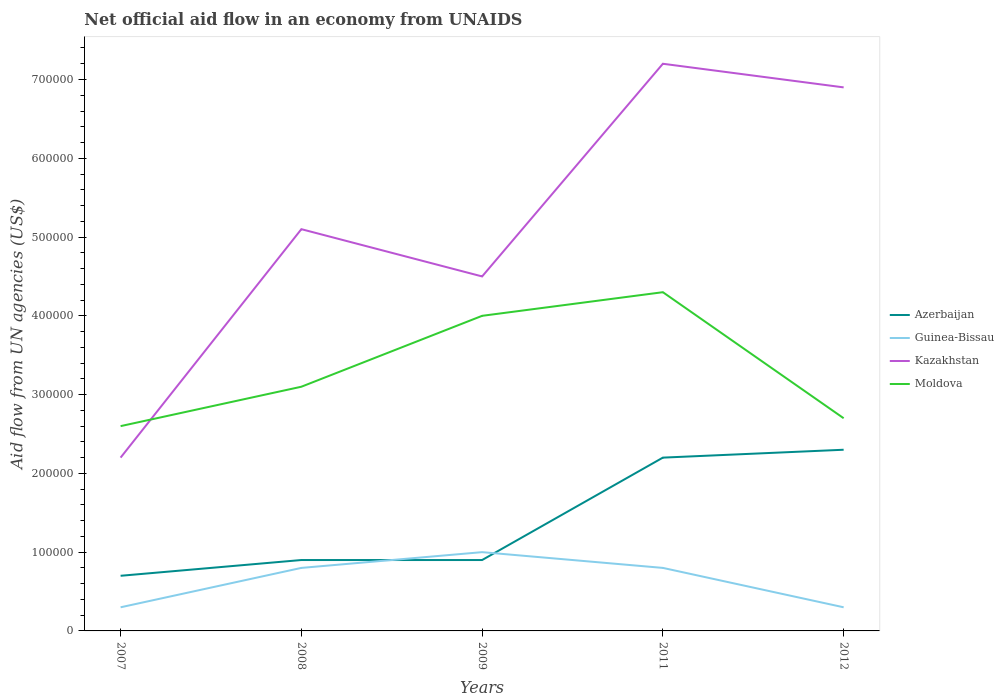Across all years, what is the maximum net official aid flow in Kazakhstan?
Offer a very short reply. 2.20e+05. In which year was the net official aid flow in Guinea-Bissau maximum?
Keep it short and to the point. 2007. What is the total net official aid flow in Kazakhstan in the graph?
Offer a very short reply. -2.40e+05. What is the difference between the highest and the second highest net official aid flow in Kazakhstan?
Keep it short and to the point. 5.00e+05. What is the difference between two consecutive major ticks on the Y-axis?
Your response must be concise. 1.00e+05. Does the graph contain any zero values?
Give a very brief answer. No. What is the title of the graph?
Give a very brief answer. Net official aid flow in an economy from UNAIDS. What is the label or title of the X-axis?
Ensure brevity in your answer.  Years. What is the label or title of the Y-axis?
Make the answer very short. Aid flow from UN agencies (US$). What is the Aid flow from UN agencies (US$) of Azerbaijan in 2007?
Provide a short and direct response. 7.00e+04. What is the Aid flow from UN agencies (US$) in Kazakhstan in 2007?
Provide a succinct answer. 2.20e+05. What is the Aid flow from UN agencies (US$) in Guinea-Bissau in 2008?
Offer a terse response. 8.00e+04. What is the Aid flow from UN agencies (US$) of Kazakhstan in 2008?
Your response must be concise. 5.10e+05. What is the Aid flow from UN agencies (US$) in Moldova in 2008?
Ensure brevity in your answer.  3.10e+05. What is the Aid flow from UN agencies (US$) of Azerbaijan in 2009?
Your response must be concise. 9.00e+04. What is the Aid flow from UN agencies (US$) in Moldova in 2009?
Make the answer very short. 4.00e+05. What is the Aid flow from UN agencies (US$) in Kazakhstan in 2011?
Offer a terse response. 7.20e+05. What is the Aid flow from UN agencies (US$) in Azerbaijan in 2012?
Make the answer very short. 2.30e+05. What is the Aid flow from UN agencies (US$) in Guinea-Bissau in 2012?
Your answer should be compact. 3.00e+04. What is the Aid flow from UN agencies (US$) in Kazakhstan in 2012?
Provide a short and direct response. 6.90e+05. What is the Aid flow from UN agencies (US$) in Moldova in 2012?
Offer a terse response. 2.70e+05. Across all years, what is the maximum Aid flow from UN agencies (US$) in Azerbaijan?
Ensure brevity in your answer.  2.30e+05. Across all years, what is the maximum Aid flow from UN agencies (US$) in Kazakhstan?
Offer a terse response. 7.20e+05. Across all years, what is the maximum Aid flow from UN agencies (US$) in Moldova?
Offer a very short reply. 4.30e+05. Across all years, what is the minimum Aid flow from UN agencies (US$) of Azerbaijan?
Offer a terse response. 7.00e+04. What is the total Aid flow from UN agencies (US$) in Azerbaijan in the graph?
Provide a short and direct response. 7.00e+05. What is the total Aid flow from UN agencies (US$) of Guinea-Bissau in the graph?
Ensure brevity in your answer.  3.20e+05. What is the total Aid flow from UN agencies (US$) in Kazakhstan in the graph?
Your response must be concise. 2.59e+06. What is the total Aid flow from UN agencies (US$) of Moldova in the graph?
Your answer should be very brief. 1.67e+06. What is the difference between the Aid flow from UN agencies (US$) in Azerbaijan in 2007 and that in 2008?
Keep it short and to the point. -2.00e+04. What is the difference between the Aid flow from UN agencies (US$) in Guinea-Bissau in 2007 and that in 2008?
Offer a terse response. -5.00e+04. What is the difference between the Aid flow from UN agencies (US$) of Azerbaijan in 2007 and that in 2009?
Offer a very short reply. -2.00e+04. What is the difference between the Aid flow from UN agencies (US$) in Guinea-Bissau in 2007 and that in 2011?
Offer a terse response. -5.00e+04. What is the difference between the Aid flow from UN agencies (US$) in Kazakhstan in 2007 and that in 2011?
Offer a very short reply. -5.00e+05. What is the difference between the Aid flow from UN agencies (US$) of Kazakhstan in 2007 and that in 2012?
Your answer should be very brief. -4.70e+05. What is the difference between the Aid flow from UN agencies (US$) of Azerbaijan in 2008 and that in 2009?
Make the answer very short. 0. What is the difference between the Aid flow from UN agencies (US$) in Guinea-Bissau in 2008 and that in 2009?
Keep it short and to the point. -2.00e+04. What is the difference between the Aid flow from UN agencies (US$) in Kazakhstan in 2008 and that in 2009?
Your response must be concise. 6.00e+04. What is the difference between the Aid flow from UN agencies (US$) in Moldova in 2008 and that in 2009?
Provide a short and direct response. -9.00e+04. What is the difference between the Aid flow from UN agencies (US$) in Kazakhstan in 2008 and that in 2011?
Offer a very short reply. -2.10e+05. What is the difference between the Aid flow from UN agencies (US$) in Guinea-Bissau in 2008 and that in 2012?
Your answer should be compact. 5.00e+04. What is the difference between the Aid flow from UN agencies (US$) in Kazakhstan in 2008 and that in 2012?
Give a very brief answer. -1.80e+05. What is the difference between the Aid flow from UN agencies (US$) of Moldova in 2008 and that in 2012?
Offer a terse response. 4.00e+04. What is the difference between the Aid flow from UN agencies (US$) in Guinea-Bissau in 2009 and that in 2011?
Provide a short and direct response. 2.00e+04. What is the difference between the Aid flow from UN agencies (US$) in Kazakhstan in 2009 and that in 2011?
Keep it short and to the point. -2.70e+05. What is the difference between the Aid flow from UN agencies (US$) of Moldova in 2009 and that in 2011?
Provide a short and direct response. -3.00e+04. What is the difference between the Aid flow from UN agencies (US$) of Azerbaijan in 2009 and that in 2012?
Your answer should be compact. -1.40e+05. What is the difference between the Aid flow from UN agencies (US$) in Kazakhstan in 2009 and that in 2012?
Your answer should be very brief. -2.40e+05. What is the difference between the Aid flow from UN agencies (US$) of Moldova in 2009 and that in 2012?
Offer a terse response. 1.30e+05. What is the difference between the Aid flow from UN agencies (US$) in Kazakhstan in 2011 and that in 2012?
Provide a short and direct response. 3.00e+04. What is the difference between the Aid flow from UN agencies (US$) in Moldova in 2011 and that in 2012?
Keep it short and to the point. 1.60e+05. What is the difference between the Aid flow from UN agencies (US$) of Azerbaijan in 2007 and the Aid flow from UN agencies (US$) of Kazakhstan in 2008?
Your answer should be very brief. -4.40e+05. What is the difference between the Aid flow from UN agencies (US$) of Azerbaijan in 2007 and the Aid flow from UN agencies (US$) of Moldova in 2008?
Offer a terse response. -2.40e+05. What is the difference between the Aid flow from UN agencies (US$) of Guinea-Bissau in 2007 and the Aid flow from UN agencies (US$) of Kazakhstan in 2008?
Make the answer very short. -4.80e+05. What is the difference between the Aid flow from UN agencies (US$) in Guinea-Bissau in 2007 and the Aid flow from UN agencies (US$) in Moldova in 2008?
Ensure brevity in your answer.  -2.80e+05. What is the difference between the Aid flow from UN agencies (US$) of Kazakhstan in 2007 and the Aid flow from UN agencies (US$) of Moldova in 2008?
Your response must be concise. -9.00e+04. What is the difference between the Aid flow from UN agencies (US$) in Azerbaijan in 2007 and the Aid flow from UN agencies (US$) in Kazakhstan in 2009?
Give a very brief answer. -3.80e+05. What is the difference between the Aid flow from UN agencies (US$) of Azerbaijan in 2007 and the Aid flow from UN agencies (US$) of Moldova in 2009?
Your response must be concise. -3.30e+05. What is the difference between the Aid flow from UN agencies (US$) of Guinea-Bissau in 2007 and the Aid flow from UN agencies (US$) of Kazakhstan in 2009?
Keep it short and to the point. -4.20e+05. What is the difference between the Aid flow from UN agencies (US$) of Guinea-Bissau in 2007 and the Aid flow from UN agencies (US$) of Moldova in 2009?
Provide a short and direct response. -3.70e+05. What is the difference between the Aid flow from UN agencies (US$) in Kazakhstan in 2007 and the Aid flow from UN agencies (US$) in Moldova in 2009?
Your answer should be compact. -1.80e+05. What is the difference between the Aid flow from UN agencies (US$) in Azerbaijan in 2007 and the Aid flow from UN agencies (US$) in Kazakhstan in 2011?
Keep it short and to the point. -6.50e+05. What is the difference between the Aid flow from UN agencies (US$) of Azerbaijan in 2007 and the Aid flow from UN agencies (US$) of Moldova in 2011?
Make the answer very short. -3.60e+05. What is the difference between the Aid flow from UN agencies (US$) of Guinea-Bissau in 2007 and the Aid flow from UN agencies (US$) of Kazakhstan in 2011?
Keep it short and to the point. -6.90e+05. What is the difference between the Aid flow from UN agencies (US$) in Guinea-Bissau in 2007 and the Aid flow from UN agencies (US$) in Moldova in 2011?
Ensure brevity in your answer.  -4.00e+05. What is the difference between the Aid flow from UN agencies (US$) in Kazakhstan in 2007 and the Aid flow from UN agencies (US$) in Moldova in 2011?
Offer a terse response. -2.10e+05. What is the difference between the Aid flow from UN agencies (US$) in Azerbaijan in 2007 and the Aid flow from UN agencies (US$) in Guinea-Bissau in 2012?
Provide a short and direct response. 4.00e+04. What is the difference between the Aid flow from UN agencies (US$) of Azerbaijan in 2007 and the Aid flow from UN agencies (US$) of Kazakhstan in 2012?
Ensure brevity in your answer.  -6.20e+05. What is the difference between the Aid flow from UN agencies (US$) in Guinea-Bissau in 2007 and the Aid flow from UN agencies (US$) in Kazakhstan in 2012?
Provide a succinct answer. -6.60e+05. What is the difference between the Aid flow from UN agencies (US$) of Guinea-Bissau in 2007 and the Aid flow from UN agencies (US$) of Moldova in 2012?
Make the answer very short. -2.40e+05. What is the difference between the Aid flow from UN agencies (US$) of Kazakhstan in 2007 and the Aid flow from UN agencies (US$) of Moldova in 2012?
Your response must be concise. -5.00e+04. What is the difference between the Aid flow from UN agencies (US$) of Azerbaijan in 2008 and the Aid flow from UN agencies (US$) of Guinea-Bissau in 2009?
Your response must be concise. -10000. What is the difference between the Aid flow from UN agencies (US$) of Azerbaijan in 2008 and the Aid flow from UN agencies (US$) of Kazakhstan in 2009?
Your response must be concise. -3.60e+05. What is the difference between the Aid flow from UN agencies (US$) of Azerbaijan in 2008 and the Aid flow from UN agencies (US$) of Moldova in 2009?
Provide a short and direct response. -3.10e+05. What is the difference between the Aid flow from UN agencies (US$) of Guinea-Bissau in 2008 and the Aid flow from UN agencies (US$) of Kazakhstan in 2009?
Your answer should be very brief. -3.70e+05. What is the difference between the Aid flow from UN agencies (US$) of Guinea-Bissau in 2008 and the Aid flow from UN agencies (US$) of Moldova in 2009?
Your response must be concise. -3.20e+05. What is the difference between the Aid flow from UN agencies (US$) of Kazakhstan in 2008 and the Aid flow from UN agencies (US$) of Moldova in 2009?
Ensure brevity in your answer.  1.10e+05. What is the difference between the Aid flow from UN agencies (US$) in Azerbaijan in 2008 and the Aid flow from UN agencies (US$) in Guinea-Bissau in 2011?
Provide a succinct answer. 10000. What is the difference between the Aid flow from UN agencies (US$) in Azerbaijan in 2008 and the Aid flow from UN agencies (US$) in Kazakhstan in 2011?
Offer a terse response. -6.30e+05. What is the difference between the Aid flow from UN agencies (US$) of Guinea-Bissau in 2008 and the Aid flow from UN agencies (US$) of Kazakhstan in 2011?
Your answer should be compact. -6.40e+05. What is the difference between the Aid flow from UN agencies (US$) in Guinea-Bissau in 2008 and the Aid flow from UN agencies (US$) in Moldova in 2011?
Make the answer very short. -3.50e+05. What is the difference between the Aid flow from UN agencies (US$) in Kazakhstan in 2008 and the Aid flow from UN agencies (US$) in Moldova in 2011?
Offer a terse response. 8.00e+04. What is the difference between the Aid flow from UN agencies (US$) in Azerbaijan in 2008 and the Aid flow from UN agencies (US$) in Kazakhstan in 2012?
Give a very brief answer. -6.00e+05. What is the difference between the Aid flow from UN agencies (US$) of Azerbaijan in 2008 and the Aid flow from UN agencies (US$) of Moldova in 2012?
Your answer should be compact. -1.80e+05. What is the difference between the Aid flow from UN agencies (US$) in Guinea-Bissau in 2008 and the Aid flow from UN agencies (US$) in Kazakhstan in 2012?
Provide a succinct answer. -6.10e+05. What is the difference between the Aid flow from UN agencies (US$) of Guinea-Bissau in 2008 and the Aid flow from UN agencies (US$) of Moldova in 2012?
Provide a short and direct response. -1.90e+05. What is the difference between the Aid flow from UN agencies (US$) in Kazakhstan in 2008 and the Aid flow from UN agencies (US$) in Moldova in 2012?
Your response must be concise. 2.40e+05. What is the difference between the Aid flow from UN agencies (US$) in Azerbaijan in 2009 and the Aid flow from UN agencies (US$) in Guinea-Bissau in 2011?
Your response must be concise. 10000. What is the difference between the Aid flow from UN agencies (US$) in Azerbaijan in 2009 and the Aid flow from UN agencies (US$) in Kazakhstan in 2011?
Your answer should be compact. -6.30e+05. What is the difference between the Aid flow from UN agencies (US$) of Guinea-Bissau in 2009 and the Aid flow from UN agencies (US$) of Kazakhstan in 2011?
Your response must be concise. -6.20e+05. What is the difference between the Aid flow from UN agencies (US$) in Guinea-Bissau in 2009 and the Aid flow from UN agencies (US$) in Moldova in 2011?
Provide a short and direct response. -3.30e+05. What is the difference between the Aid flow from UN agencies (US$) of Azerbaijan in 2009 and the Aid flow from UN agencies (US$) of Guinea-Bissau in 2012?
Offer a terse response. 6.00e+04. What is the difference between the Aid flow from UN agencies (US$) of Azerbaijan in 2009 and the Aid flow from UN agencies (US$) of Kazakhstan in 2012?
Make the answer very short. -6.00e+05. What is the difference between the Aid flow from UN agencies (US$) of Guinea-Bissau in 2009 and the Aid flow from UN agencies (US$) of Kazakhstan in 2012?
Ensure brevity in your answer.  -5.90e+05. What is the difference between the Aid flow from UN agencies (US$) in Azerbaijan in 2011 and the Aid flow from UN agencies (US$) in Kazakhstan in 2012?
Ensure brevity in your answer.  -4.70e+05. What is the difference between the Aid flow from UN agencies (US$) of Azerbaijan in 2011 and the Aid flow from UN agencies (US$) of Moldova in 2012?
Make the answer very short. -5.00e+04. What is the difference between the Aid flow from UN agencies (US$) of Guinea-Bissau in 2011 and the Aid flow from UN agencies (US$) of Kazakhstan in 2012?
Provide a succinct answer. -6.10e+05. What is the difference between the Aid flow from UN agencies (US$) in Kazakhstan in 2011 and the Aid flow from UN agencies (US$) in Moldova in 2012?
Your answer should be very brief. 4.50e+05. What is the average Aid flow from UN agencies (US$) of Guinea-Bissau per year?
Your response must be concise. 6.40e+04. What is the average Aid flow from UN agencies (US$) of Kazakhstan per year?
Give a very brief answer. 5.18e+05. What is the average Aid flow from UN agencies (US$) of Moldova per year?
Make the answer very short. 3.34e+05. In the year 2007, what is the difference between the Aid flow from UN agencies (US$) in Azerbaijan and Aid flow from UN agencies (US$) in Guinea-Bissau?
Provide a short and direct response. 4.00e+04. In the year 2007, what is the difference between the Aid flow from UN agencies (US$) of Guinea-Bissau and Aid flow from UN agencies (US$) of Moldova?
Your answer should be compact. -2.30e+05. In the year 2007, what is the difference between the Aid flow from UN agencies (US$) of Kazakhstan and Aid flow from UN agencies (US$) of Moldova?
Provide a succinct answer. -4.00e+04. In the year 2008, what is the difference between the Aid flow from UN agencies (US$) in Azerbaijan and Aid flow from UN agencies (US$) in Guinea-Bissau?
Make the answer very short. 10000. In the year 2008, what is the difference between the Aid flow from UN agencies (US$) in Azerbaijan and Aid flow from UN agencies (US$) in Kazakhstan?
Provide a succinct answer. -4.20e+05. In the year 2008, what is the difference between the Aid flow from UN agencies (US$) of Azerbaijan and Aid flow from UN agencies (US$) of Moldova?
Provide a succinct answer. -2.20e+05. In the year 2008, what is the difference between the Aid flow from UN agencies (US$) of Guinea-Bissau and Aid flow from UN agencies (US$) of Kazakhstan?
Give a very brief answer. -4.30e+05. In the year 2008, what is the difference between the Aid flow from UN agencies (US$) in Guinea-Bissau and Aid flow from UN agencies (US$) in Moldova?
Ensure brevity in your answer.  -2.30e+05. In the year 2009, what is the difference between the Aid flow from UN agencies (US$) in Azerbaijan and Aid flow from UN agencies (US$) in Guinea-Bissau?
Offer a very short reply. -10000. In the year 2009, what is the difference between the Aid flow from UN agencies (US$) in Azerbaijan and Aid flow from UN agencies (US$) in Kazakhstan?
Your response must be concise. -3.60e+05. In the year 2009, what is the difference between the Aid flow from UN agencies (US$) of Azerbaijan and Aid flow from UN agencies (US$) of Moldova?
Your answer should be very brief. -3.10e+05. In the year 2009, what is the difference between the Aid flow from UN agencies (US$) in Guinea-Bissau and Aid flow from UN agencies (US$) in Kazakhstan?
Your answer should be very brief. -3.50e+05. In the year 2011, what is the difference between the Aid flow from UN agencies (US$) of Azerbaijan and Aid flow from UN agencies (US$) of Kazakhstan?
Your response must be concise. -5.00e+05. In the year 2011, what is the difference between the Aid flow from UN agencies (US$) in Guinea-Bissau and Aid flow from UN agencies (US$) in Kazakhstan?
Keep it short and to the point. -6.40e+05. In the year 2011, what is the difference between the Aid flow from UN agencies (US$) of Guinea-Bissau and Aid flow from UN agencies (US$) of Moldova?
Provide a short and direct response. -3.50e+05. In the year 2012, what is the difference between the Aid flow from UN agencies (US$) in Azerbaijan and Aid flow from UN agencies (US$) in Guinea-Bissau?
Ensure brevity in your answer.  2.00e+05. In the year 2012, what is the difference between the Aid flow from UN agencies (US$) in Azerbaijan and Aid flow from UN agencies (US$) in Kazakhstan?
Your answer should be very brief. -4.60e+05. In the year 2012, what is the difference between the Aid flow from UN agencies (US$) of Azerbaijan and Aid flow from UN agencies (US$) of Moldova?
Provide a succinct answer. -4.00e+04. In the year 2012, what is the difference between the Aid flow from UN agencies (US$) of Guinea-Bissau and Aid flow from UN agencies (US$) of Kazakhstan?
Keep it short and to the point. -6.60e+05. In the year 2012, what is the difference between the Aid flow from UN agencies (US$) in Guinea-Bissau and Aid flow from UN agencies (US$) in Moldova?
Make the answer very short. -2.40e+05. What is the ratio of the Aid flow from UN agencies (US$) in Azerbaijan in 2007 to that in 2008?
Your response must be concise. 0.78. What is the ratio of the Aid flow from UN agencies (US$) of Guinea-Bissau in 2007 to that in 2008?
Your answer should be very brief. 0.38. What is the ratio of the Aid flow from UN agencies (US$) in Kazakhstan in 2007 to that in 2008?
Provide a succinct answer. 0.43. What is the ratio of the Aid flow from UN agencies (US$) in Moldova in 2007 to that in 2008?
Your answer should be compact. 0.84. What is the ratio of the Aid flow from UN agencies (US$) in Kazakhstan in 2007 to that in 2009?
Make the answer very short. 0.49. What is the ratio of the Aid flow from UN agencies (US$) in Moldova in 2007 to that in 2009?
Offer a very short reply. 0.65. What is the ratio of the Aid flow from UN agencies (US$) in Azerbaijan in 2007 to that in 2011?
Give a very brief answer. 0.32. What is the ratio of the Aid flow from UN agencies (US$) of Guinea-Bissau in 2007 to that in 2011?
Your response must be concise. 0.38. What is the ratio of the Aid flow from UN agencies (US$) of Kazakhstan in 2007 to that in 2011?
Your answer should be very brief. 0.31. What is the ratio of the Aid flow from UN agencies (US$) of Moldova in 2007 to that in 2011?
Give a very brief answer. 0.6. What is the ratio of the Aid flow from UN agencies (US$) of Azerbaijan in 2007 to that in 2012?
Keep it short and to the point. 0.3. What is the ratio of the Aid flow from UN agencies (US$) of Kazakhstan in 2007 to that in 2012?
Provide a succinct answer. 0.32. What is the ratio of the Aid flow from UN agencies (US$) in Moldova in 2007 to that in 2012?
Offer a very short reply. 0.96. What is the ratio of the Aid flow from UN agencies (US$) of Azerbaijan in 2008 to that in 2009?
Provide a short and direct response. 1. What is the ratio of the Aid flow from UN agencies (US$) in Guinea-Bissau in 2008 to that in 2009?
Provide a succinct answer. 0.8. What is the ratio of the Aid flow from UN agencies (US$) in Kazakhstan in 2008 to that in 2009?
Make the answer very short. 1.13. What is the ratio of the Aid flow from UN agencies (US$) of Moldova in 2008 to that in 2009?
Provide a short and direct response. 0.78. What is the ratio of the Aid flow from UN agencies (US$) in Azerbaijan in 2008 to that in 2011?
Provide a short and direct response. 0.41. What is the ratio of the Aid flow from UN agencies (US$) in Guinea-Bissau in 2008 to that in 2011?
Your response must be concise. 1. What is the ratio of the Aid flow from UN agencies (US$) of Kazakhstan in 2008 to that in 2011?
Offer a very short reply. 0.71. What is the ratio of the Aid flow from UN agencies (US$) of Moldova in 2008 to that in 2011?
Provide a short and direct response. 0.72. What is the ratio of the Aid flow from UN agencies (US$) of Azerbaijan in 2008 to that in 2012?
Offer a very short reply. 0.39. What is the ratio of the Aid flow from UN agencies (US$) in Guinea-Bissau in 2008 to that in 2012?
Ensure brevity in your answer.  2.67. What is the ratio of the Aid flow from UN agencies (US$) of Kazakhstan in 2008 to that in 2012?
Your response must be concise. 0.74. What is the ratio of the Aid flow from UN agencies (US$) of Moldova in 2008 to that in 2012?
Make the answer very short. 1.15. What is the ratio of the Aid flow from UN agencies (US$) in Azerbaijan in 2009 to that in 2011?
Keep it short and to the point. 0.41. What is the ratio of the Aid flow from UN agencies (US$) of Moldova in 2009 to that in 2011?
Provide a short and direct response. 0.93. What is the ratio of the Aid flow from UN agencies (US$) in Azerbaijan in 2009 to that in 2012?
Make the answer very short. 0.39. What is the ratio of the Aid flow from UN agencies (US$) of Guinea-Bissau in 2009 to that in 2012?
Give a very brief answer. 3.33. What is the ratio of the Aid flow from UN agencies (US$) of Kazakhstan in 2009 to that in 2012?
Your answer should be very brief. 0.65. What is the ratio of the Aid flow from UN agencies (US$) in Moldova in 2009 to that in 2012?
Your answer should be very brief. 1.48. What is the ratio of the Aid flow from UN agencies (US$) of Azerbaijan in 2011 to that in 2012?
Your answer should be very brief. 0.96. What is the ratio of the Aid flow from UN agencies (US$) of Guinea-Bissau in 2011 to that in 2012?
Make the answer very short. 2.67. What is the ratio of the Aid flow from UN agencies (US$) of Kazakhstan in 2011 to that in 2012?
Your answer should be very brief. 1.04. What is the ratio of the Aid flow from UN agencies (US$) in Moldova in 2011 to that in 2012?
Make the answer very short. 1.59. What is the difference between the highest and the second highest Aid flow from UN agencies (US$) of Azerbaijan?
Keep it short and to the point. 10000. What is the difference between the highest and the second highest Aid flow from UN agencies (US$) of Kazakhstan?
Your answer should be very brief. 3.00e+04. What is the difference between the highest and the lowest Aid flow from UN agencies (US$) in Azerbaijan?
Provide a short and direct response. 1.60e+05. 